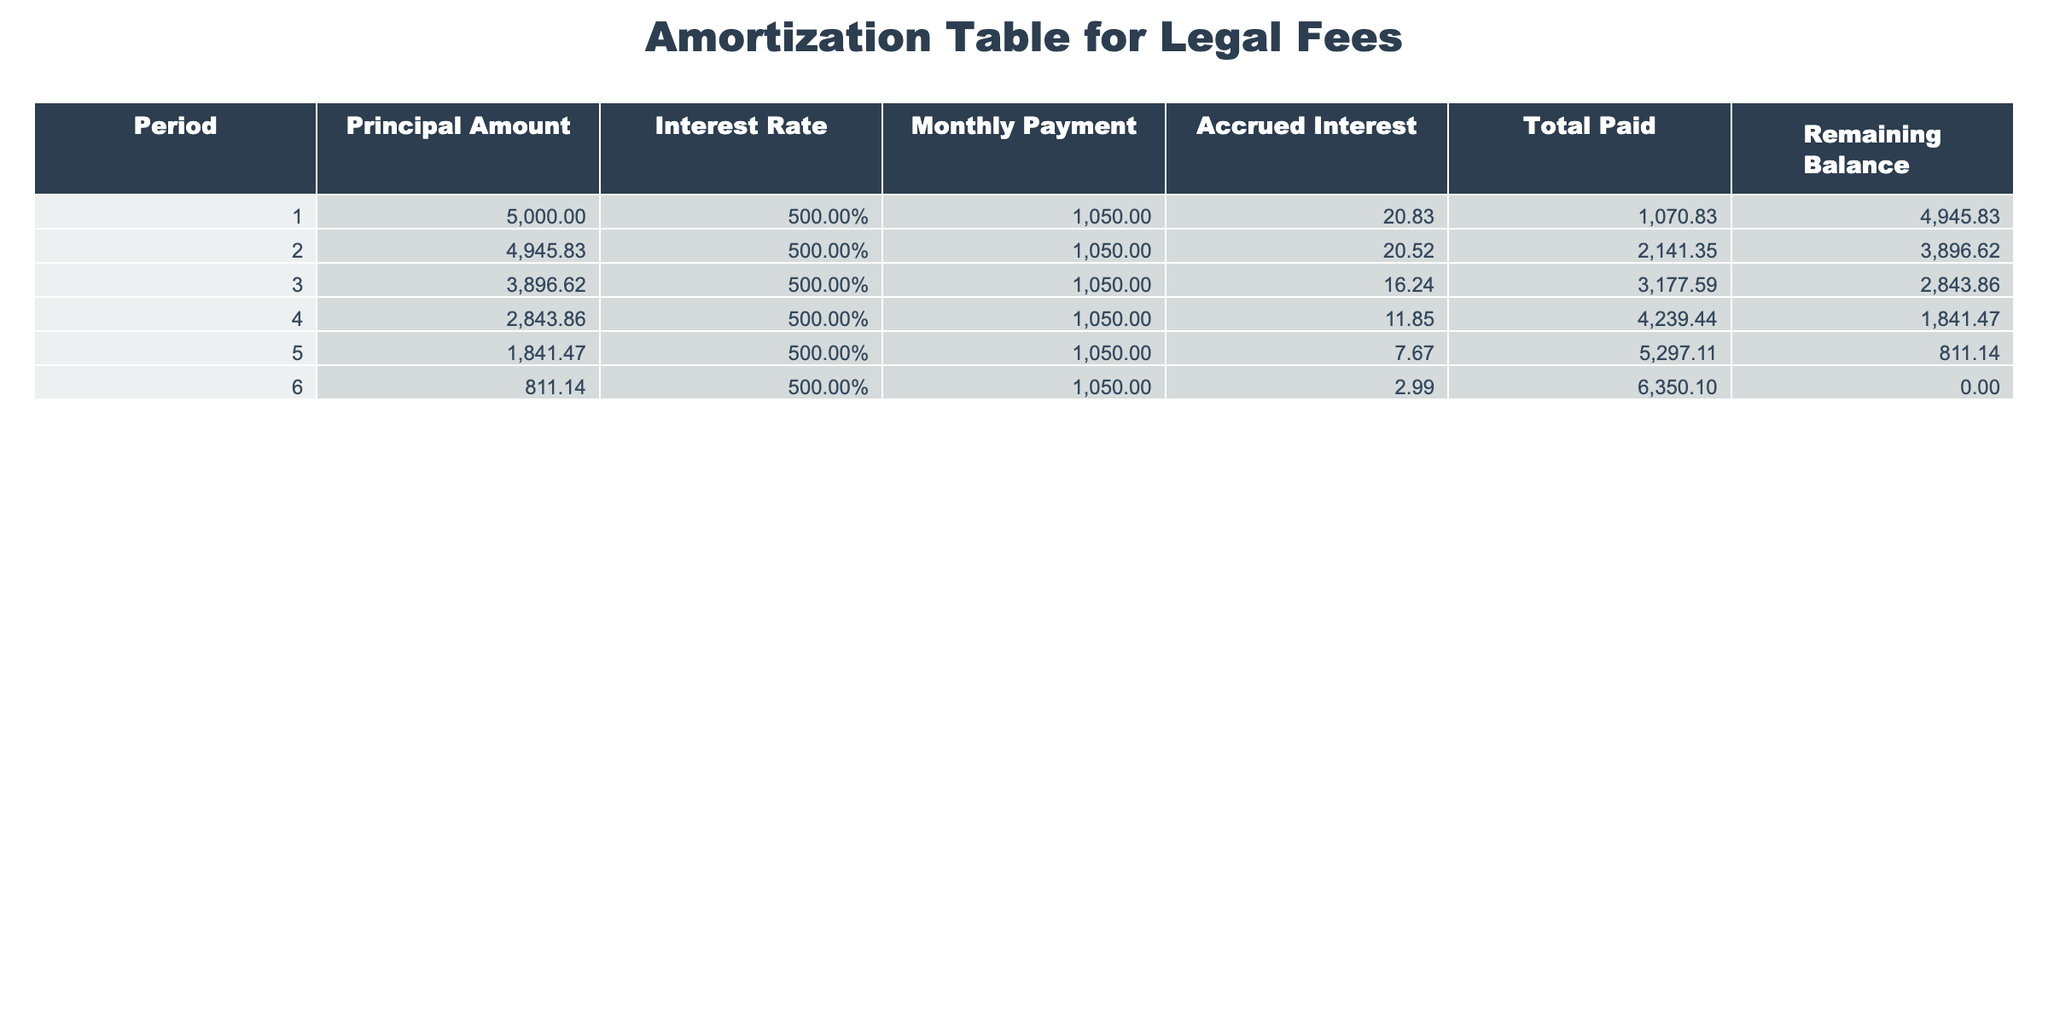What is the total paid amount by the end of period 5? In period 5, the total paid amount is recorded as 5297.11. This is the cumulative total from all previous payments up to that point.
Answer: 5297.11 What is the remaining balance after the first payment? After the first payment, the remaining balance is 4945.83 as noted in period 1 of the table, indicating the principal amount after accounting for the first monthly payment.
Answer: 4945.83 How much interest is accrued by the end of period 4? By the end of period 4, the total accrued interest is 4239.44. This figure represents the sum of interest accrued over the first four periods.
Answer: 4239.44 What is the average monthly payment over all periods? The monthly payment is consistent at 1050 for all six periods. Therefore, the average monthly payment is the same: 1050.
Answer: 1050 Is the remaining balance after period 6 zero? Yes, the remaining balance after period 6 is 0.00, indicating that the entire principal has been paid off by the end of this period.
Answer: Yes How much total money was paid in interest by the end of all periods? To find the total interest paid, sum the accrued interest at the end of each period: 20.83 + 20.52 + 16.24 + 11.85 + 7.67 + 2.99 = 80.1. Thus, the total interest paid is 80.1.
Answer: 80.1 What is the highest accrued interest in one period? The highest accrued interest occurred in period 1 with 20.83, as recorded in the table. This is the greatest single instance of interest accrued in any period.
Answer: 20.83 What is the remaining balance after the second payment? After the second payment, the remaining balance drops to 3896.62, as detailed in period 2 of the table, reflecting the new balance following the payments made thus far.
Answer: 3896.62 What is the total amount paid in the first three periods? To calculate the total amount paid in the first three periods, sum the monthly payments for those periods: 1050 + 1050 + 1050 = 3150.
Answer: 3150 